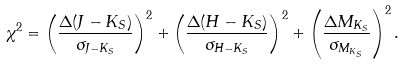Convert formula to latex. <formula><loc_0><loc_0><loc_500><loc_500>\chi ^ { 2 } = \left ( \frac { \Delta ( J - K _ { S } ) } { \sigma _ { J - K _ { S } } } \right ) ^ { 2 } + \left ( \frac { \Delta ( H - K _ { S } ) } { \sigma _ { H - K _ { S } } } \right ) ^ { 2 } + \left ( \frac { \Delta M _ { K _ { S } } } { \sigma _ { M _ { K _ { S } } } } \right ) ^ { 2 } .</formula> 